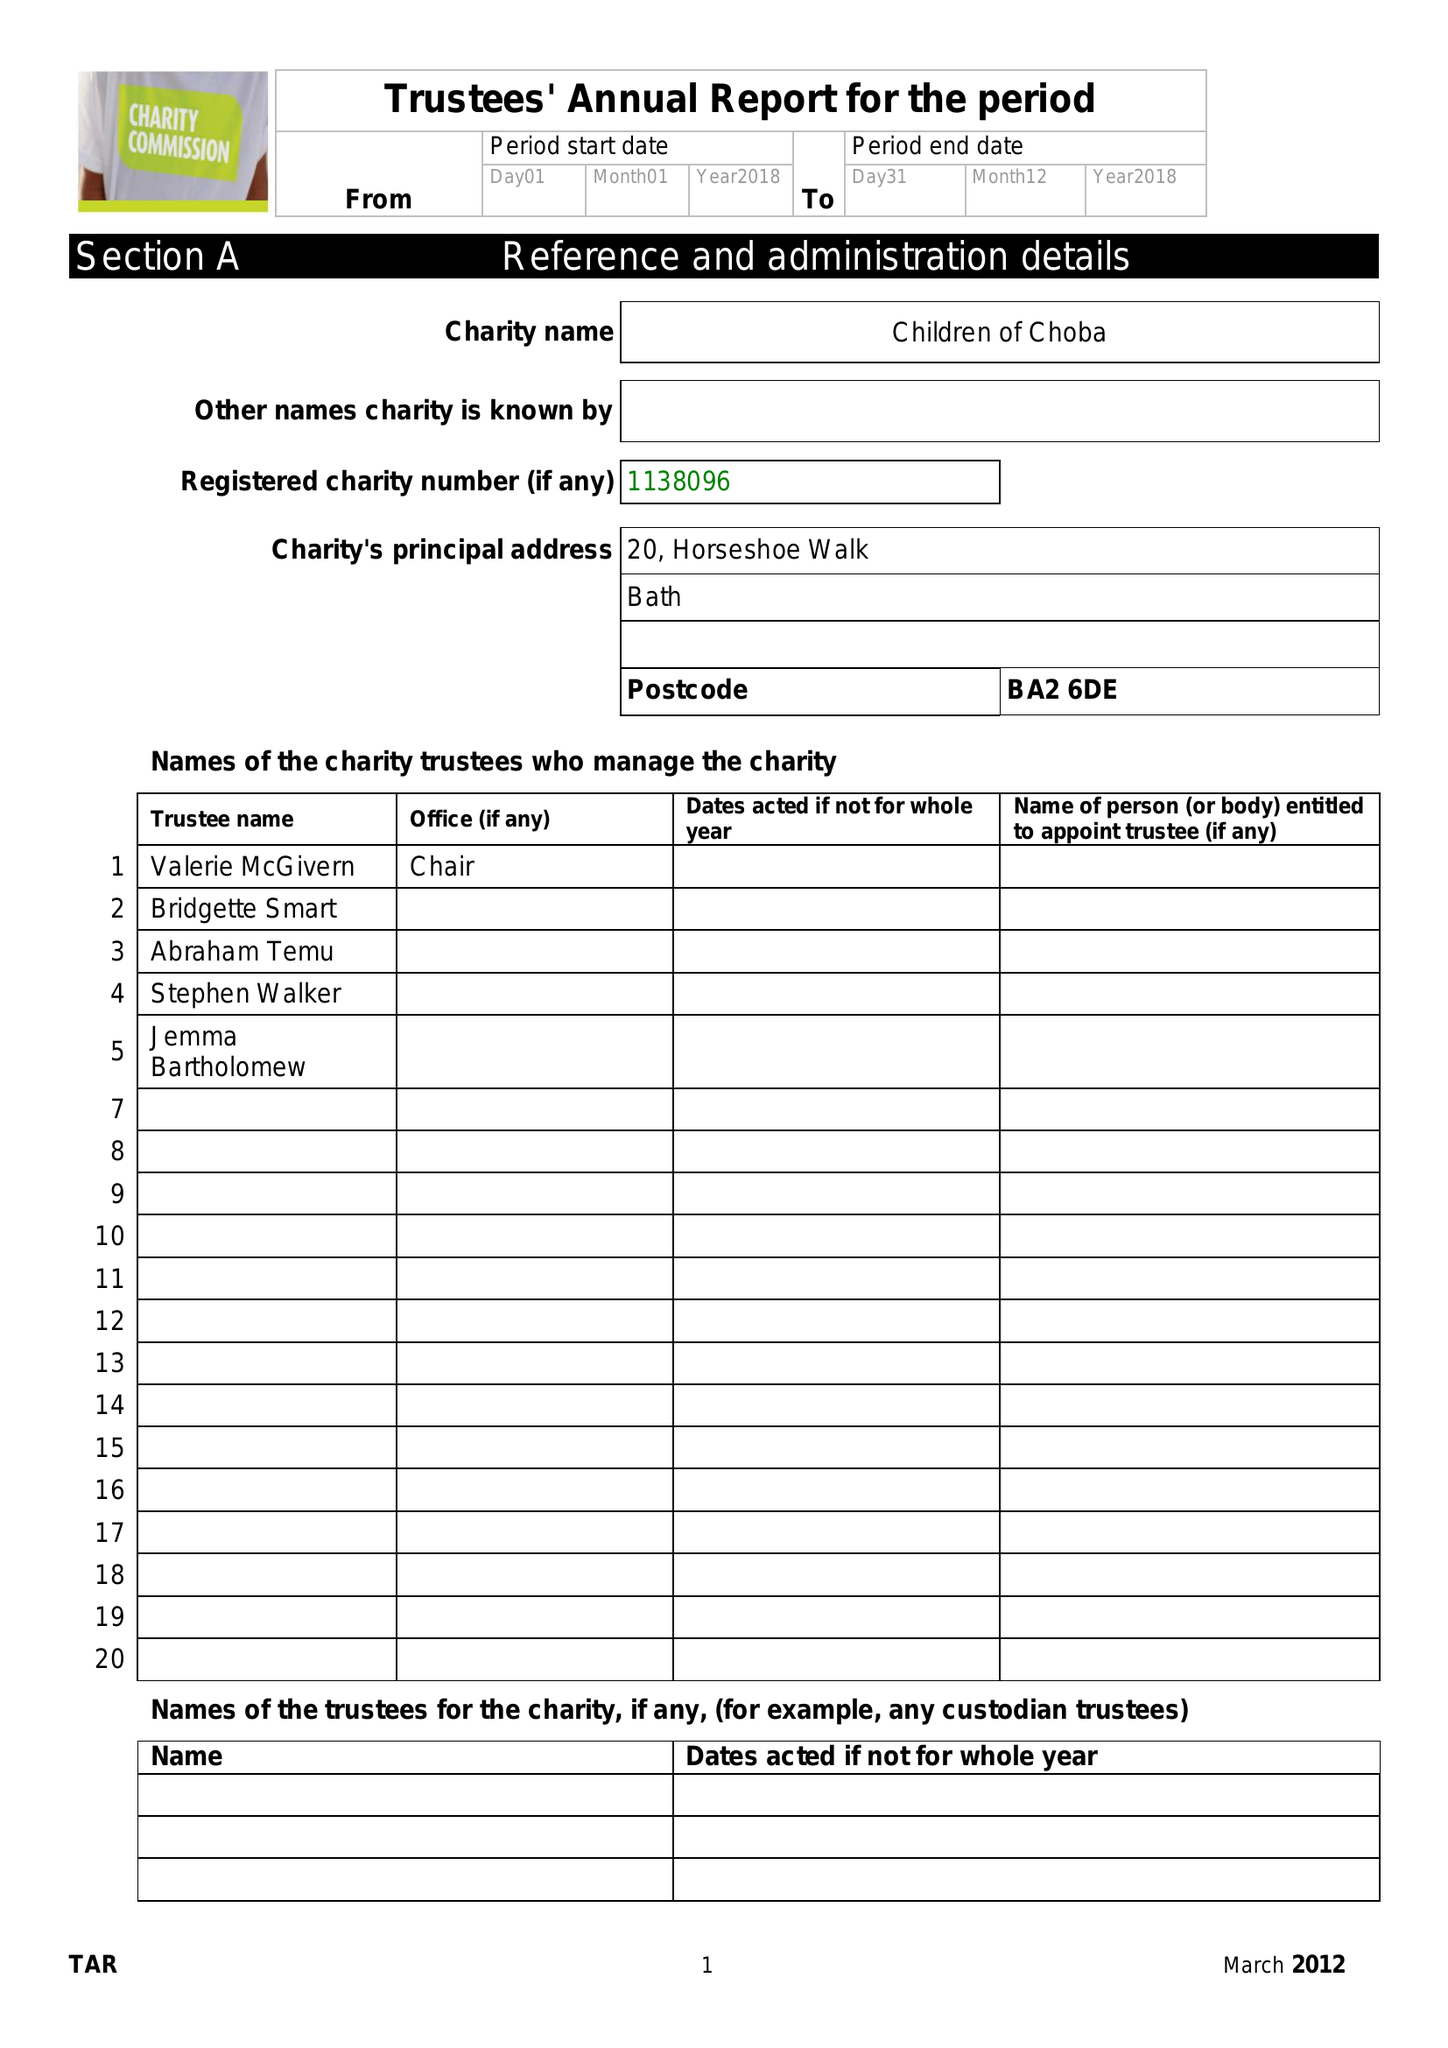What is the value for the spending_annually_in_british_pounds?
Answer the question using a single word or phrase. 51853.00 